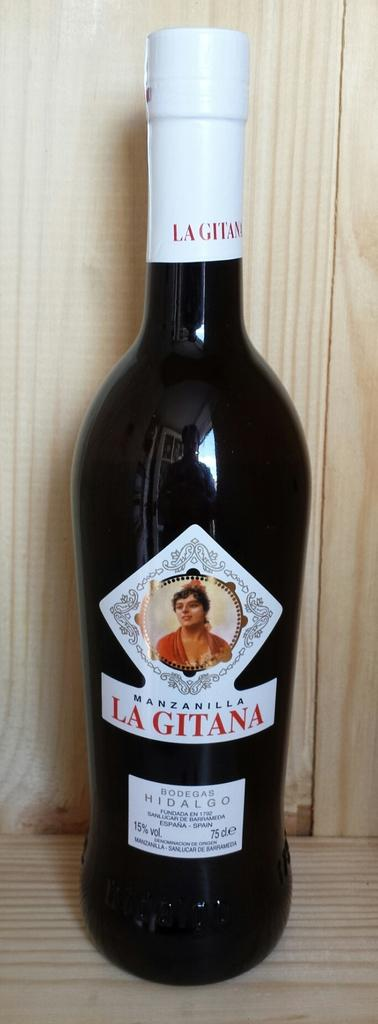<image>
Render a clear and concise summary of the photo. A dark colored bottle bearing the name Lagitana is sitting on a wooden shelf. 